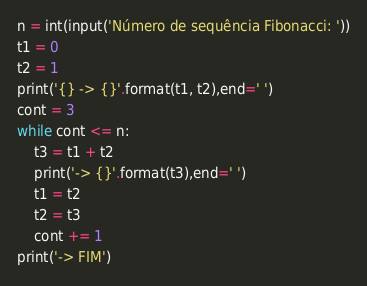Convert code to text. <code><loc_0><loc_0><loc_500><loc_500><_Python_>n = int(input('Número de sequência Fibonacci: '))
t1 = 0
t2 = 1
print('{} -> {}'.format(t1, t2),end=' ')
cont = 3
while cont <= n:
    t3 = t1 + t2
    print('-> {}'.format(t3),end=' ')
    t1 = t2
    t2 = t3
    cont += 1
print('-> FIM')</code> 